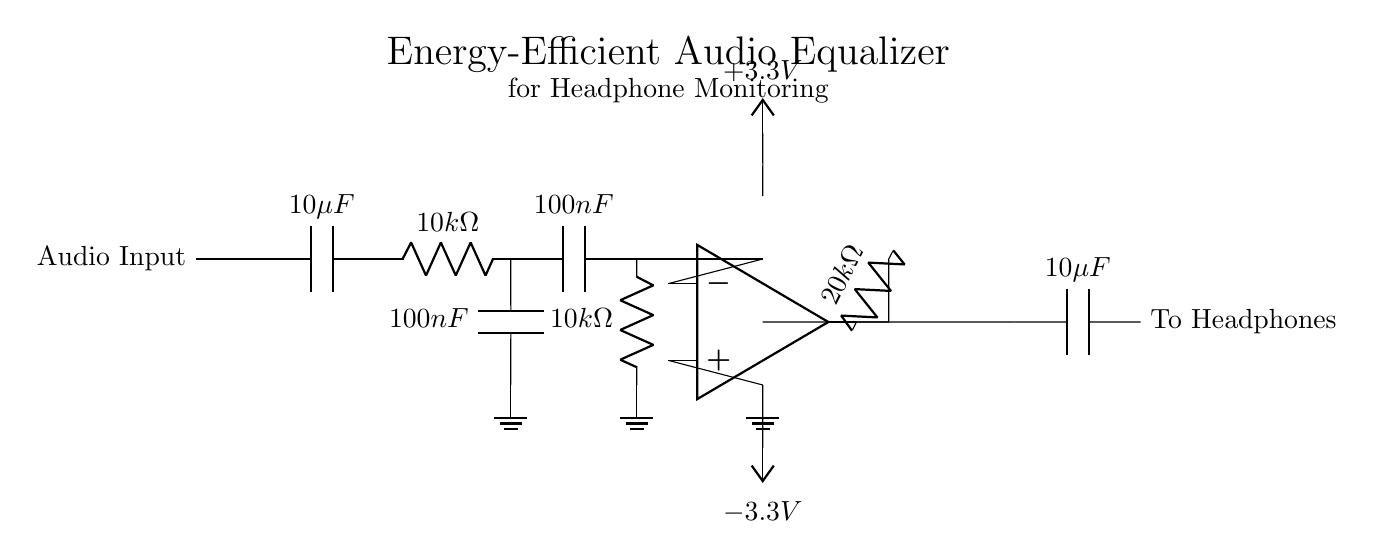What type of capacitors are used in the circuit? The circuit uses two capacitors, both labeled as 10 microfarads and one labeled as 100 nanofarads.
Answer: 10 microfarads, 100 nanofarads What is the value of the resistors in the low-pass and high-pass filters? The circuit has two resistors, each with a value of 10 kilohms for the filters, and an additional resistor of 20 kilohms in the feedback loop of the op-amp.
Answer: 10 kilohms, 20 kilohms Which component provides gain in this circuit? The operational amplifier is responsible for providing gain in the circuit, with its output connected to the feedback resistor and the output signal.
Answer: Operational amplifier What is the power supply voltage for this equalizer circuit? The equalizer circuit uses plus 3.3 volts and minus 3.3 volts as its power supply voltages, ensuring proper functionality of the operational amplifier.
Answer: 3.3 volts Describe the configuration of the filters in the circuit. The low-pass filter is constructed with a capacitor in parallel with a resistor, while the high-pass filter has a capacitor in series with the resistor. This configuration allows specific frequencies to pass through while attenuating others.
Answer: Low-pass and high-pass filters How does the feedback resistor affect the operational amplifier? The feedback resistor, which has a value of 20 kilohms, manages the gain of the operational amplifier by influencing the ratio of feedback to input voltage, hence affecting the amplifier's amplifying capability.
Answer: Increases gain What is the purpose of the capacitors in this circuit? The capacitors serve multiple purposes: one capacitor is used for coupling the audio signal to the amplifier stage, while the other is used in the low and high-pass filter configurations to manage frequency response.
Answer: Coupling and filtering 